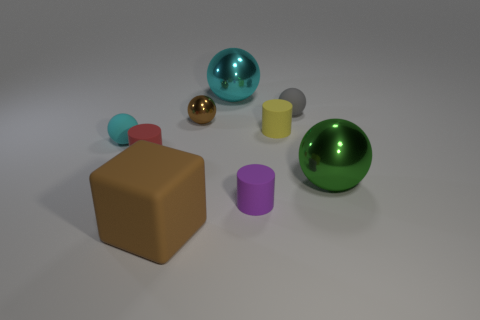How would you describe the overall composition of objects in this image? The composition presents a balanced assortment of geometric shapes with varying colors and materials. There are spherical objects with shiny surfaces reflecting light, each a distinct color. A large cube with a matte finish anchors the scene, accompanied by cylindrical shapes, one vertical and one horizontal. The arrangement is orderly, with objects spaced evenly, offering a sense of visual harmony. 